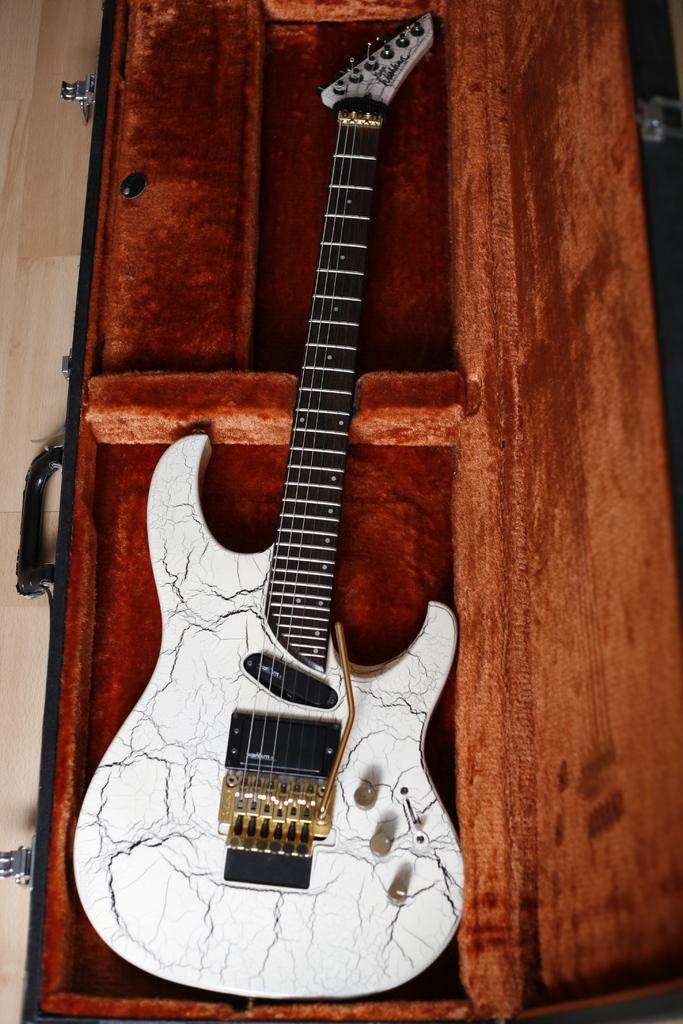What type of guitar is visible in the image? There is a white color guitar in the image. How is the guitar being stored or protected in the image? The guitar is kept in a wooden guitar case. What type of fork can be seen in the image? There is no fork present in the image; it features a white color guitar in a wooden guitar case. Is there a squirrel visible in the image? No, there is no squirrel present in the image. 